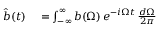Convert formula to latex. <formula><loc_0><loc_0><loc_500><loc_500>\begin{array} { r l } { \hat { b } ( t ) } & = \int _ { - \infty } ^ { \infty } b ( \Omega ) \, e ^ { - i \Omega t } \, \frac { d \Omega } { 2 \pi } } \end{array}</formula> 